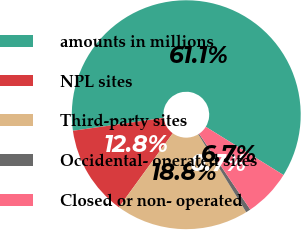Convert chart to OTSL. <chart><loc_0><loc_0><loc_500><loc_500><pie_chart><fcel>amounts in millions<fcel>NPL sites<fcel>Third-party sites<fcel>Occidental- operated sites<fcel>Closed or non- operated<nl><fcel>61.08%<fcel>12.75%<fcel>18.79%<fcel>0.67%<fcel>6.71%<nl></chart> 